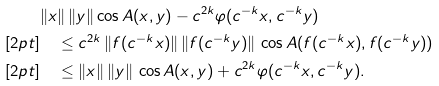Convert formula to latex. <formula><loc_0><loc_0><loc_500><loc_500>& \| x \| \, \| y \| \cos A ( x , y ) - c ^ { 2 k } \varphi ( c ^ { - k } x , c ^ { - k } y ) \\ [ 2 p t ] & \quad \leq c ^ { 2 k } \, \| f ( c ^ { - k } x ) \| \, \| f ( c ^ { - k } y ) \| \, \cos A ( f ( c ^ { - k } x ) , f ( c ^ { - k } y ) ) \\ [ 2 p t ] & \quad \leq \| x \| \, \| y \| \, \cos A ( x , y ) + c ^ { 2 k } \varphi ( c ^ { - k } x , c ^ { - k } y ) .</formula> 